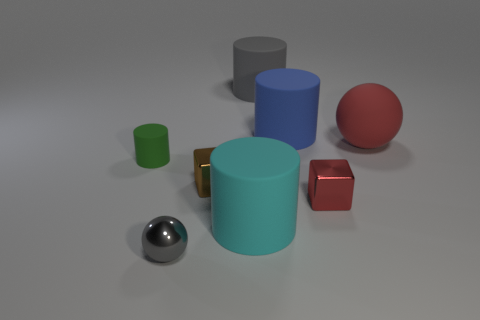Subtract 1 cylinders. How many cylinders are left? 3 Add 1 tiny red metallic cylinders. How many objects exist? 9 Subtract all balls. How many objects are left? 6 Subtract all cyan rubber cylinders. Subtract all brown metal things. How many objects are left? 6 Add 3 shiny cubes. How many shiny cubes are left? 5 Add 4 purple matte balls. How many purple matte balls exist? 4 Subtract 0 brown balls. How many objects are left? 8 